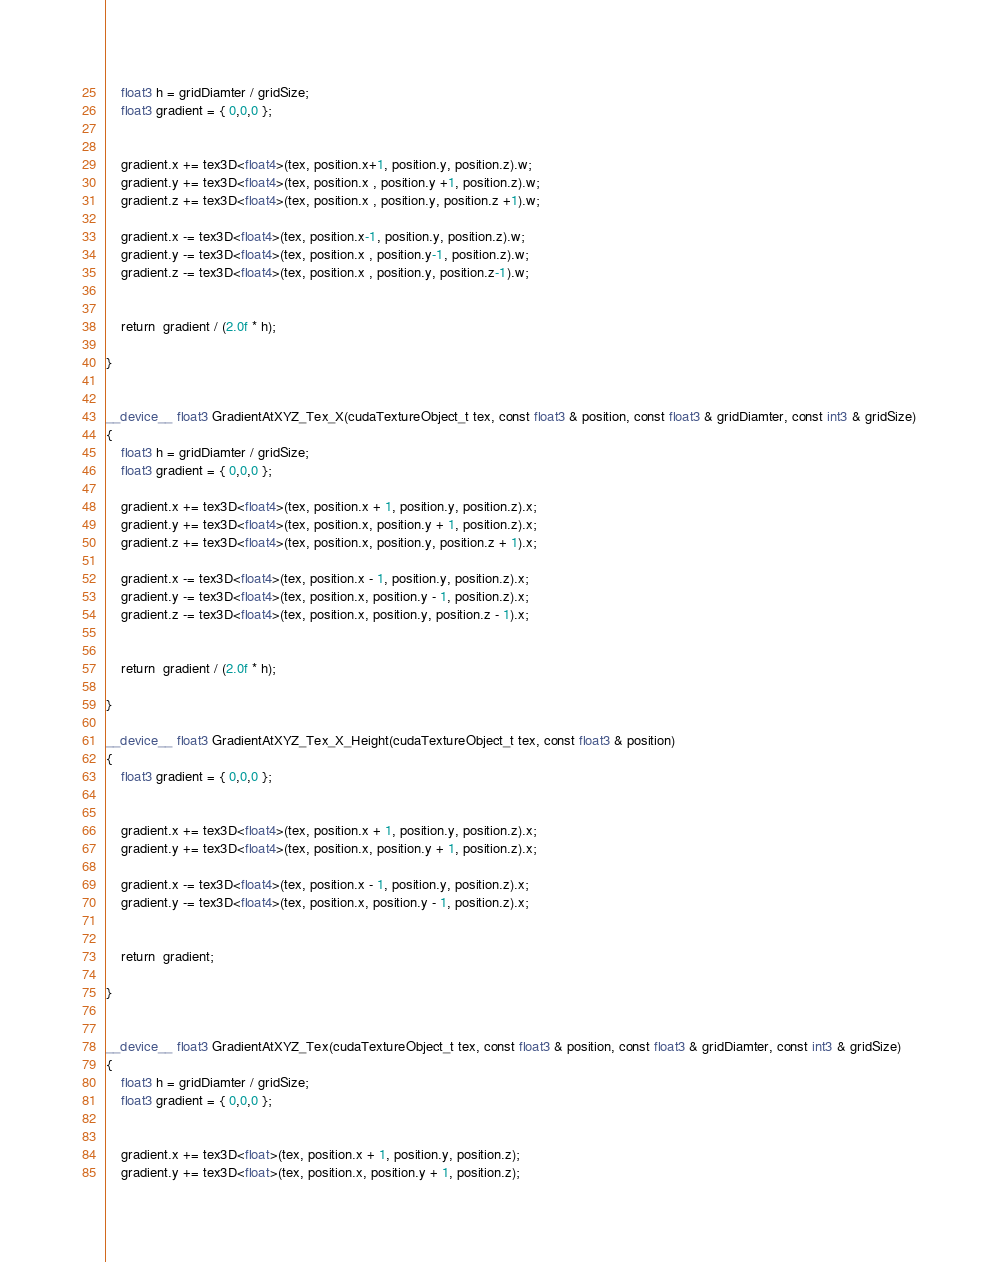<code> <loc_0><loc_0><loc_500><loc_500><_Cuda_>	float3 h = gridDiamter / gridSize;
	float3 gradient = { 0,0,0 };

	
	gradient.x += tex3D<float4>(tex, position.x+1, position.y, position.z).w;
	gradient.y += tex3D<float4>(tex, position.x , position.y +1, position.z).w;
	gradient.z += tex3D<float4>(tex, position.x , position.y, position.z +1).w;

	gradient.x -= tex3D<float4>(tex, position.x-1, position.y, position.z).w;
	gradient.y -= tex3D<float4>(tex, position.x , position.y-1, position.z).w;
	gradient.z -= tex3D<float4>(tex, position.x , position.y, position.z-1).w;


	return  gradient / (2.0f * h);

}


__device__ float3 GradientAtXYZ_Tex_X(cudaTextureObject_t tex, const float3 & position, const float3 & gridDiamter, const int3 & gridSize)
{
	float3 h = gridDiamter / gridSize;
	float3 gradient = { 0,0,0 };

	gradient.x += tex3D<float4>(tex, position.x + 1, position.y, position.z).x;
	gradient.y += tex3D<float4>(tex, position.x, position.y + 1, position.z).x;
	gradient.z += tex3D<float4>(tex, position.x, position.y, position.z + 1).x;

	gradient.x -= tex3D<float4>(tex, position.x - 1, position.y, position.z).x;
	gradient.y -= tex3D<float4>(tex, position.x, position.y - 1, position.z).x;
	gradient.z -= tex3D<float4>(tex, position.x, position.y, position.z - 1).x;


	return  gradient / (2.0f * h);

}

__device__ float3 GradientAtXYZ_Tex_X_Height(cudaTextureObject_t tex, const float3 & position)
{
	float3 gradient = { 0,0,0 };


	gradient.x += tex3D<float4>(tex, position.x + 1, position.y, position.z).x;
	gradient.y += tex3D<float4>(tex, position.x, position.y + 1, position.z).x;

	gradient.x -= tex3D<float4>(tex, position.x - 1, position.y, position.z).x;
	gradient.y -= tex3D<float4>(tex, position.x, position.y - 1, position.z).x;


	return  gradient;

}


__device__ float3 GradientAtXYZ_Tex(cudaTextureObject_t tex, const float3 & position, const float3 & gridDiamter, const int3 & gridSize)
{
	float3 h = gridDiamter / gridSize;
	float3 gradient = { 0,0,0 };


	gradient.x += tex3D<float>(tex, position.x + 1, position.y, position.z);
	gradient.y += tex3D<float>(tex, position.x, position.y + 1, position.z);</code> 